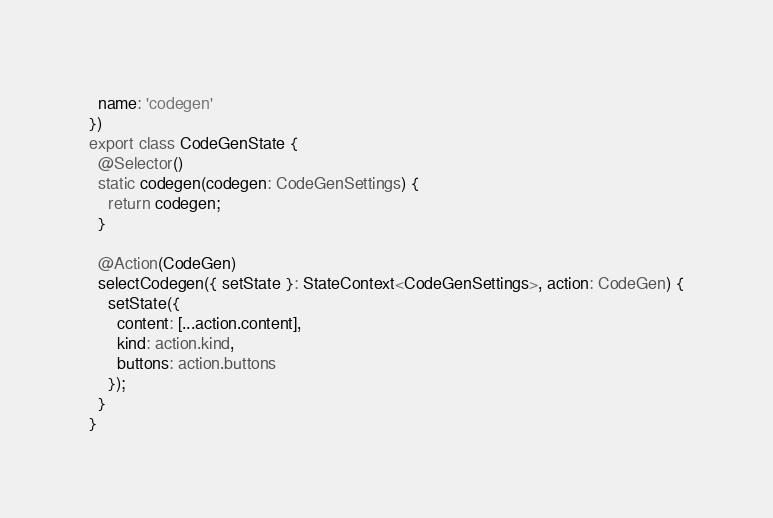Convert code to text. <code><loc_0><loc_0><loc_500><loc_500><_TypeScript_>  name: 'codegen'
})
export class CodeGenState {
  @Selector()
  static codegen(codegen: CodeGenSettings) {
    return codegen;
  }

  @Action(CodeGen)
  selectCodegen({ setState }: StateContext<CodeGenSettings>, action: CodeGen) {
    setState({
      content: [...action.content],
      kind: action.kind,
      buttons: action.buttons
    });
  }
}
</code> 